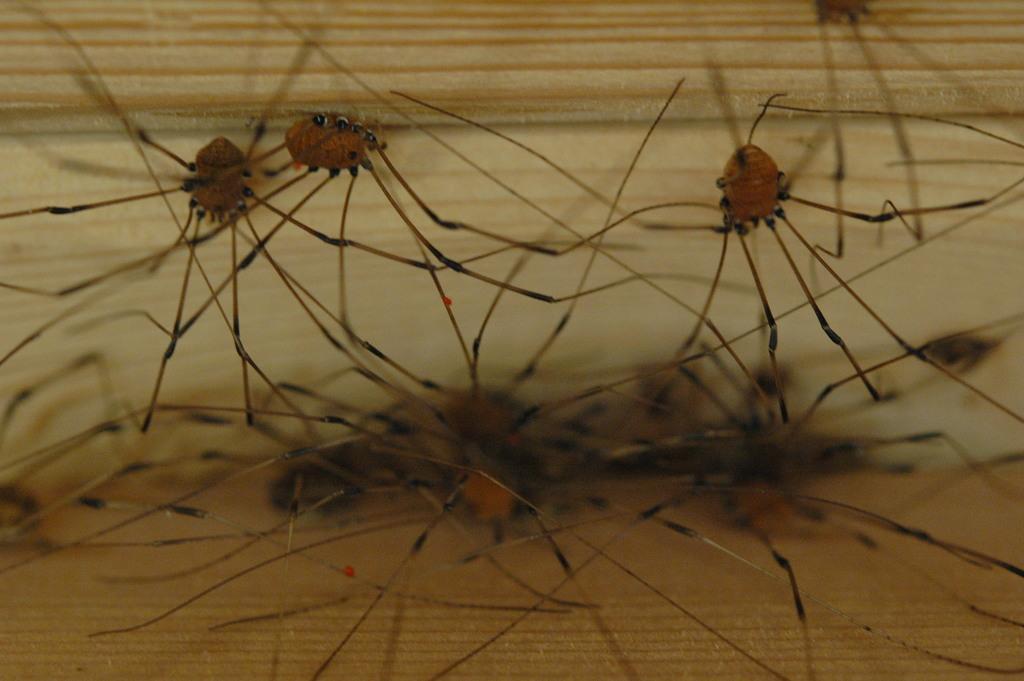Please provide a concise description of this image. In this image there are insects. 